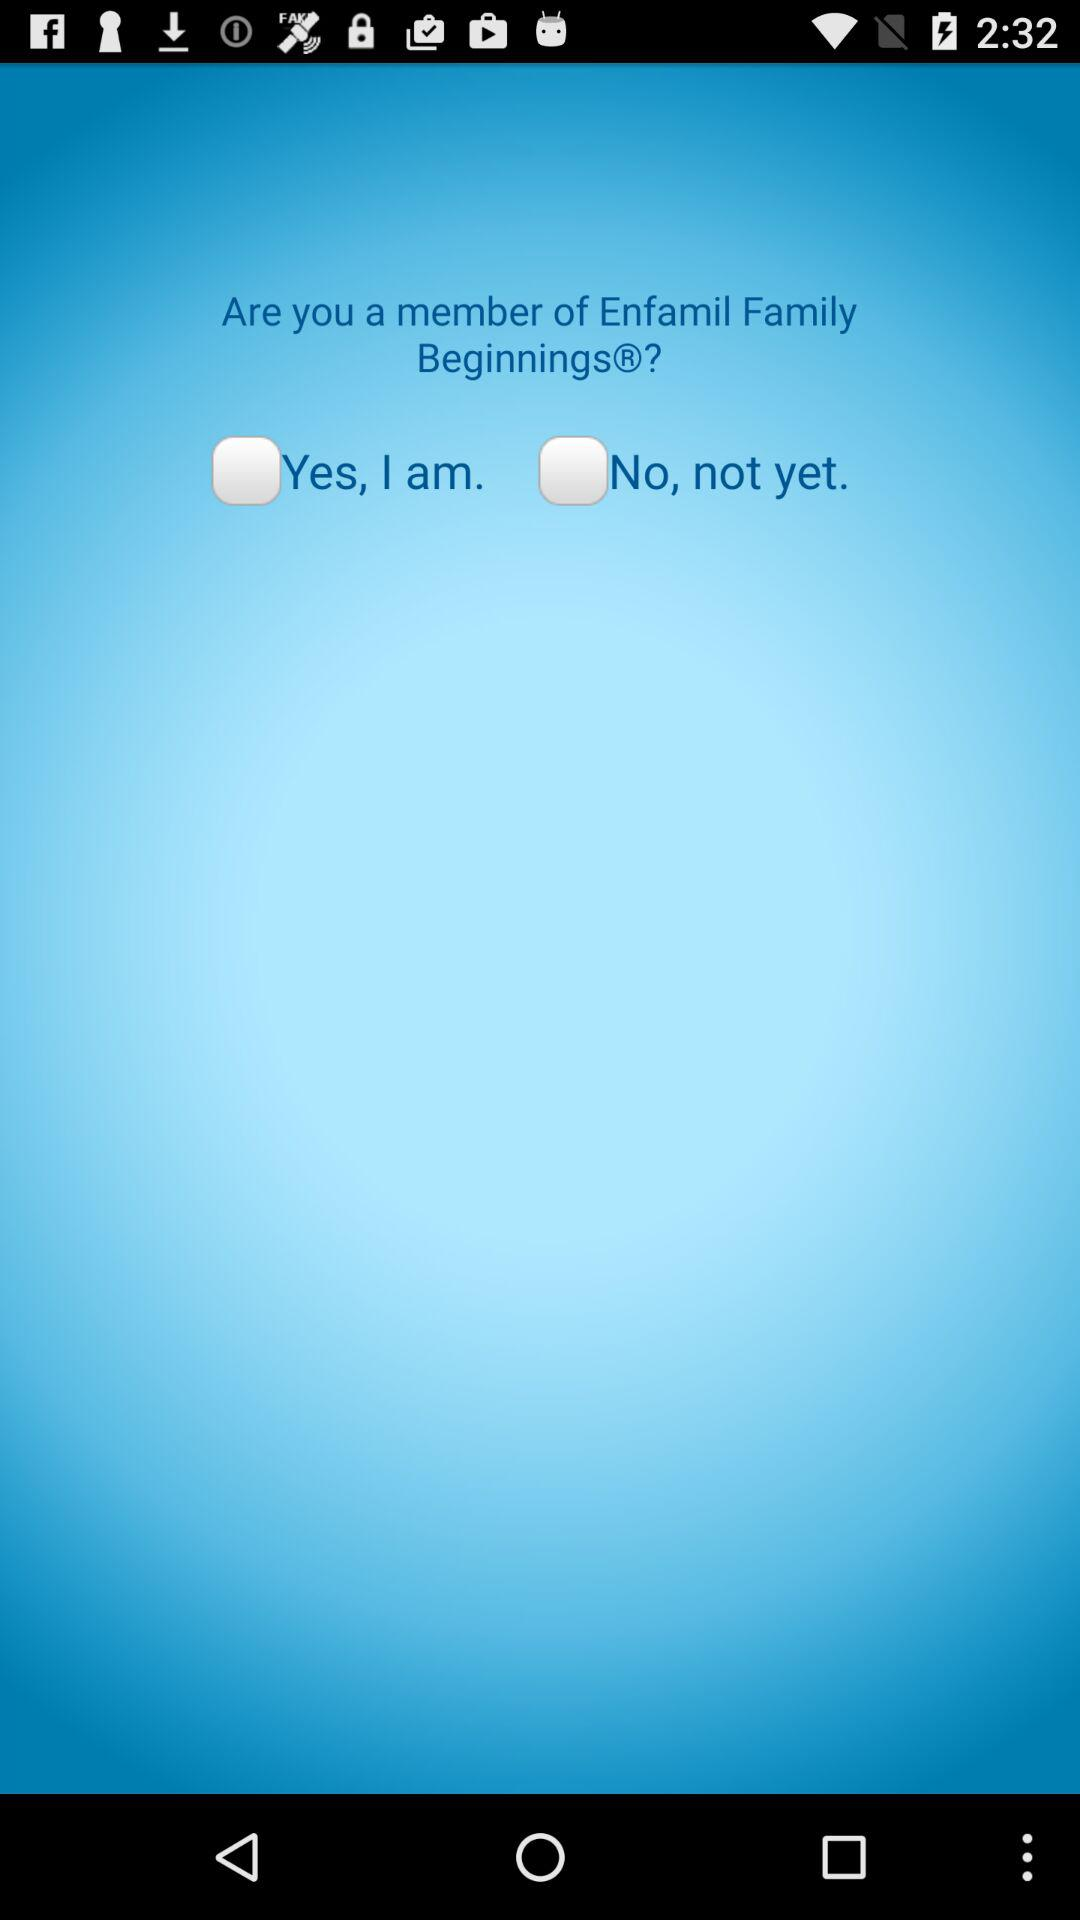Is "Yes, I am" selected or not? "Yes, I am" is not selected. 